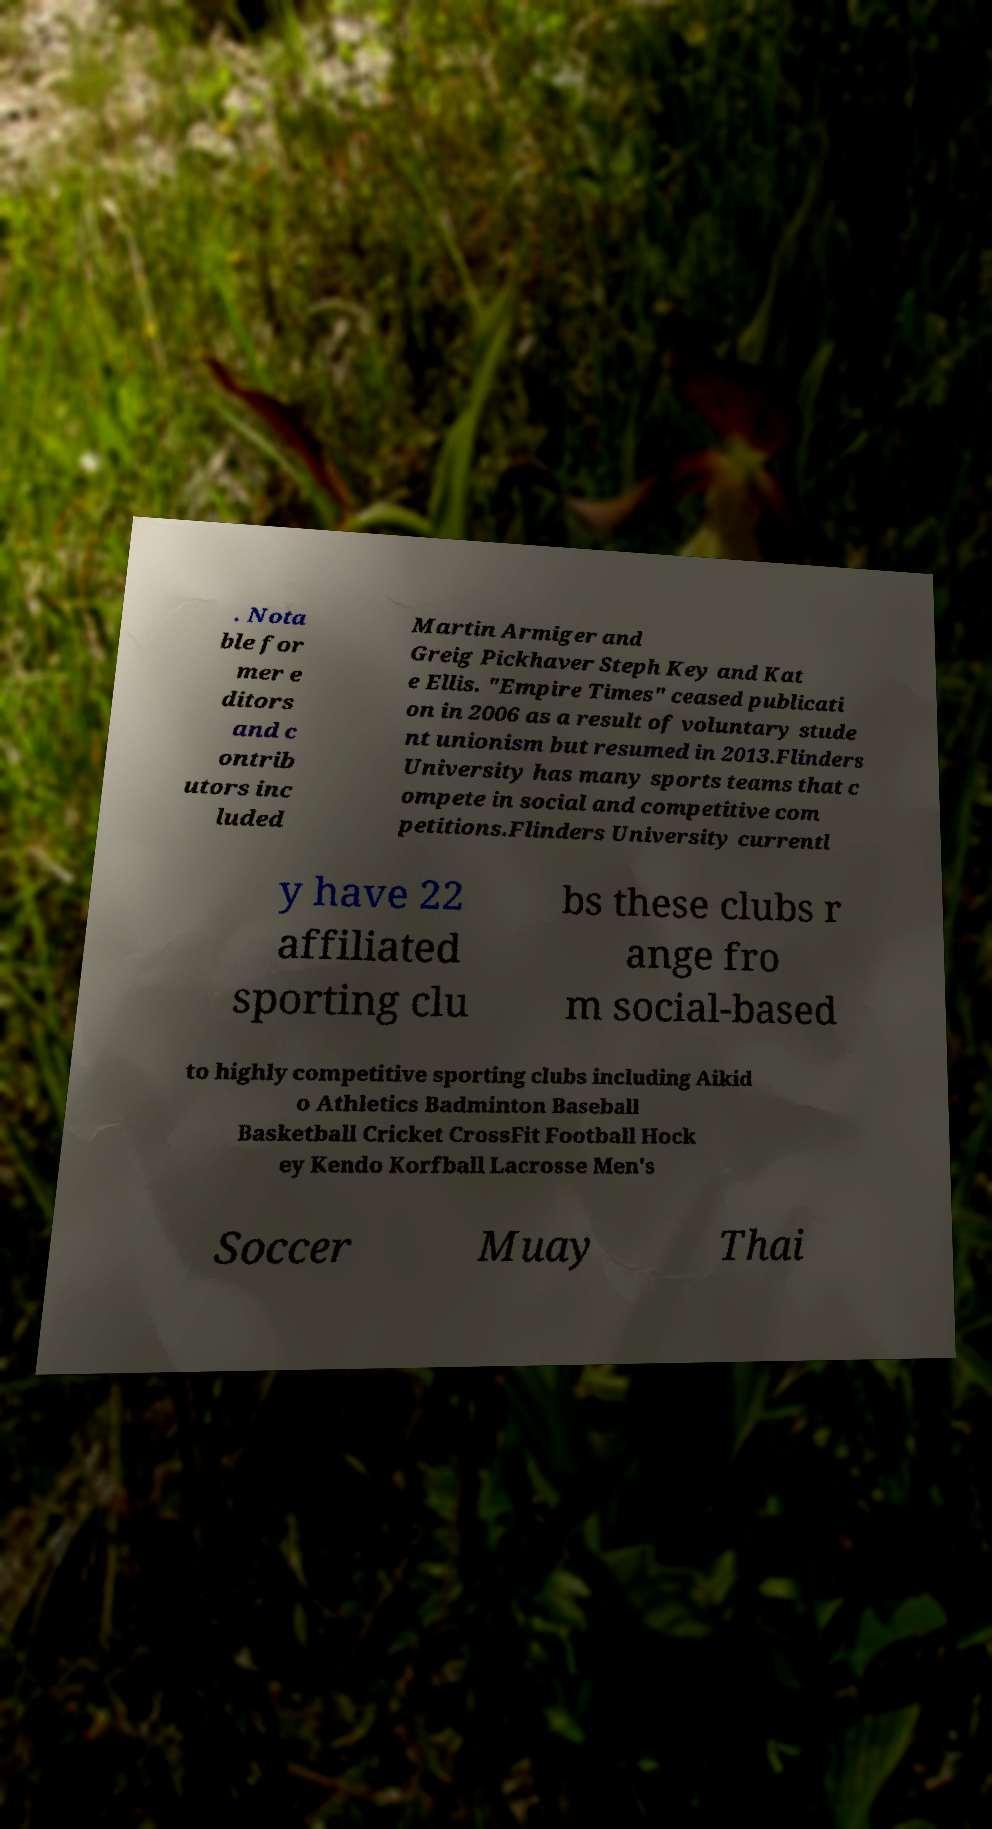Please identify and transcribe the text found in this image. . Nota ble for mer e ditors and c ontrib utors inc luded Martin Armiger and Greig Pickhaver Steph Key and Kat e Ellis. "Empire Times" ceased publicati on in 2006 as a result of voluntary stude nt unionism but resumed in 2013.Flinders University has many sports teams that c ompete in social and competitive com petitions.Flinders University currentl y have 22 affiliated sporting clu bs these clubs r ange fro m social-based to highly competitive sporting clubs including Aikid o Athletics Badminton Baseball Basketball Cricket CrossFit Football Hock ey Kendo Korfball Lacrosse Men's Soccer Muay Thai 